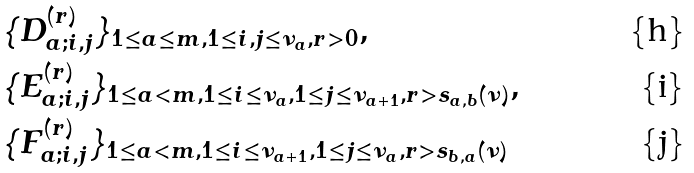Convert formula to latex. <formula><loc_0><loc_0><loc_500><loc_500>& \{ D _ { a ; i , j } ^ { ( r ) } \} _ { 1 \leq a \leq m , 1 \leq i , j \leq \nu _ { a } , r > 0 } , \\ & \{ E _ { a ; i , j } ^ { ( r ) } \} _ { 1 \leq a < m , 1 \leq i \leq \nu _ { a } , 1 \leq j \leq \nu _ { a + 1 } , r > s _ { a , b } ( \nu ) } , \\ & \{ F _ { a ; i , j } ^ { ( r ) } \} _ { 1 \leq a < m , 1 \leq i \leq \nu _ { a + 1 } , 1 \leq j \leq \nu _ { a } , r > s _ { b , a } ( \nu ) }</formula> 